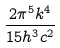Convert formula to latex. <formula><loc_0><loc_0><loc_500><loc_500>\frac { 2 \pi ^ { 5 } k ^ { 4 } } { 1 5 h ^ { 3 } c ^ { 2 } }</formula> 